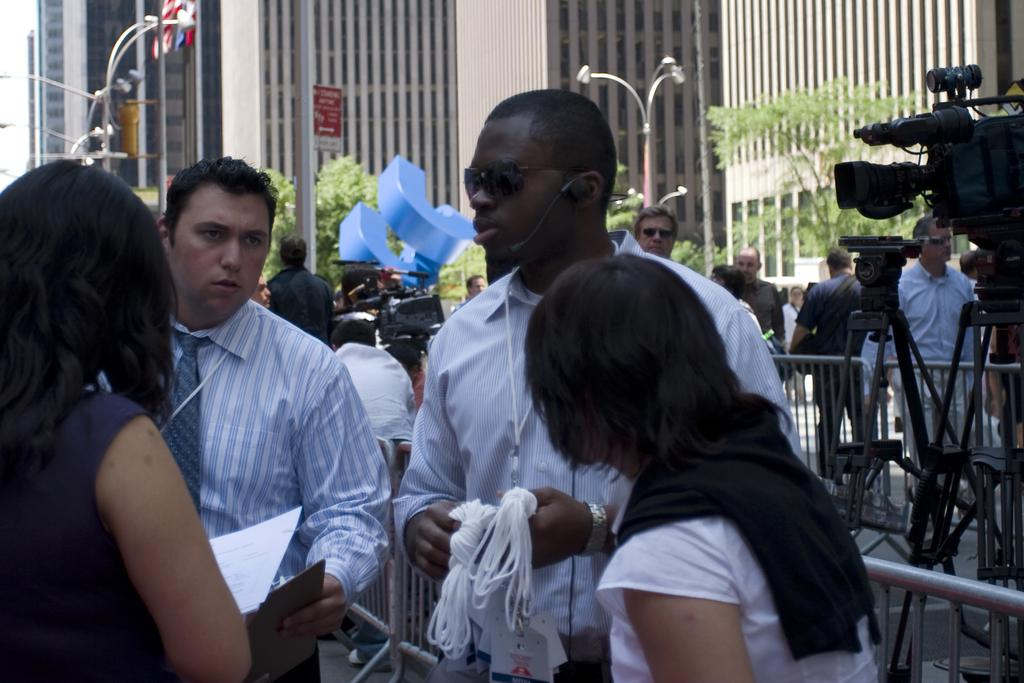Who or what can be seen in the image? There are people in the image. What is the metal fence in the image used for? The metal fence in the image is likely used for security or to separate areas. What are the cameras in the image used for? The cameras in the image are likely used for surveillance or recording purposes. Can you describe the background of the image? In the background of the image, there are light poles, buildings, and trees. How many objects can be seen in the image besides the people, fence, and cameras? There are other objects in the image, but their exact number is not specified. What type of bread is being served at the event in the image? There is no event or bread present in the image; it features people, a metal fence, cameras, and a background with light poles, buildings, and trees. 